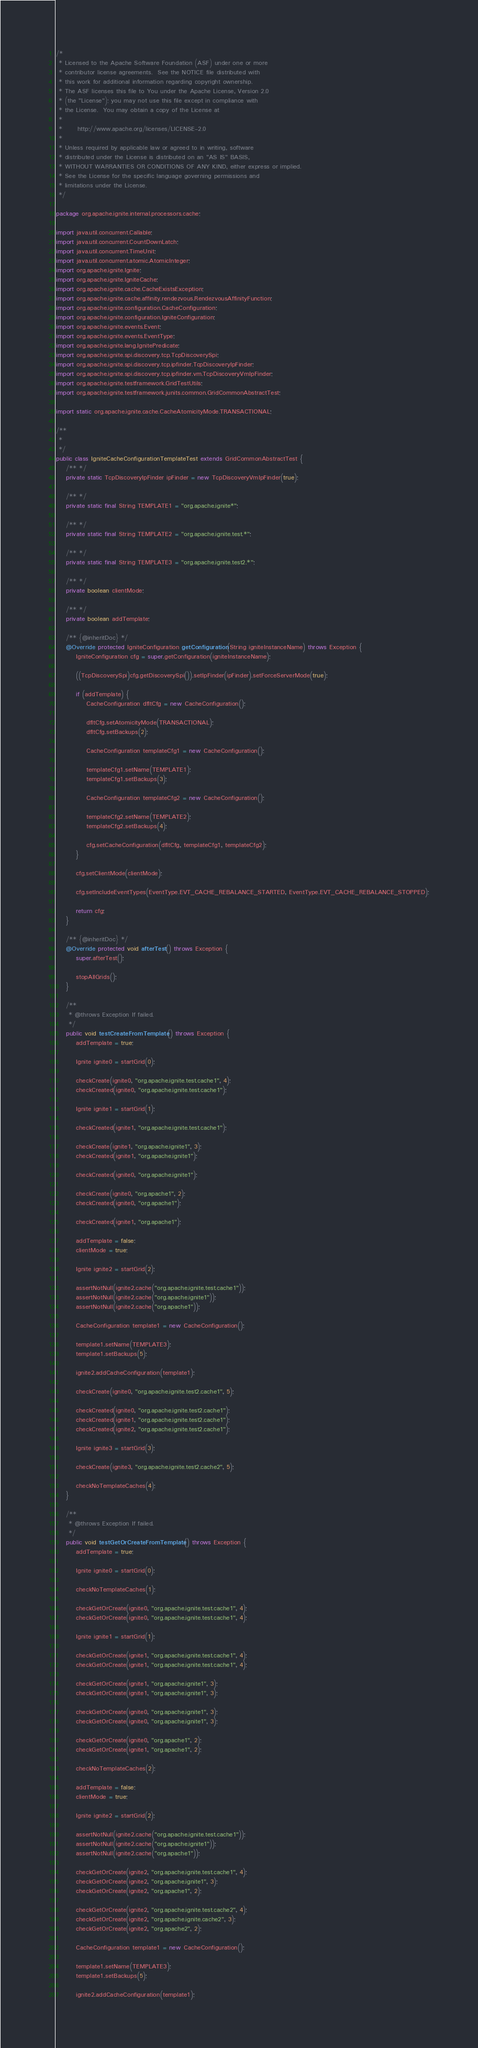<code> <loc_0><loc_0><loc_500><loc_500><_Java_>/*
 * Licensed to the Apache Software Foundation (ASF) under one or more
 * contributor license agreements.  See the NOTICE file distributed with
 * this work for additional information regarding copyright ownership.
 * The ASF licenses this file to You under the Apache License, Version 2.0
 * (the "License"); you may not use this file except in compliance with
 * the License.  You may obtain a copy of the License at
 *
 *      http://www.apache.org/licenses/LICENSE-2.0
 *
 * Unless required by applicable law or agreed to in writing, software
 * distributed under the License is distributed on an "AS IS" BASIS,
 * WITHOUT WARRANTIES OR CONDITIONS OF ANY KIND, either express or implied.
 * See the License for the specific language governing permissions and
 * limitations under the License.
 */

package org.apache.ignite.internal.processors.cache;

import java.util.concurrent.Callable;
import java.util.concurrent.CountDownLatch;
import java.util.concurrent.TimeUnit;
import java.util.concurrent.atomic.AtomicInteger;
import org.apache.ignite.Ignite;
import org.apache.ignite.IgniteCache;
import org.apache.ignite.cache.CacheExistsException;
import org.apache.ignite.cache.affinity.rendezvous.RendezvousAffinityFunction;
import org.apache.ignite.configuration.CacheConfiguration;
import org.apache.ignite.configuration.IgniteConfiguration;
import org.apache.ignite.events.Event;
import org.apache.ignite.events.EventType;
import org.apache.ignite.lang.IgnitePredicate;
import org.apache.ignite.spi.discovery.tcp.TcpDiscoverySpi;
import org.apache.ignite.spi.discovery.tcp.ipfinder.TcpDiscoveryIpFinder;
import org.apache.ignite.spi.discovery.tcp.ipfinder.vm.TcpDiscoveryVmIpFinder;
import org.apache.ignite.testframework.GridTestUtils;
import org.apache.ignite.testframework.junits.common.GridCommonAbstractTest;

import static org.apache.ignite.cache.CacheAtomicityMode.TRANSACTIONAL;

/**
 *
 */
public class IgniteCacheConfigurationTemplateTest extends GridCommonAbstractTest {
    /** */
    private static TcpDiscoveryIpFinder ipFinder = new TcpDiscoveryVmIpFinder(true);

    /** */
    private static final String TEMPLATE1 = "org.apache.ignite*";

    /** */
    private static final String TEMPLATE2 = "org.apache.ignite.test.*";

    /** */
    private static final String TEMPLATE3 = "org.apache.ignite.test2.*";

    /** */
    private boolean clientMode;

    /** */
    private boolean addTemplate;

    /** {@inheritDoc} */
    @Override protected IgniteConfiguration getConfiguration(String igniteInstanceName) throws Exception {
        IgniteConfiguration cfg = super.getConfiguration(igniteInstanceName);

        ((TcpDiscoverySpi)cfg.getDiscoverySpi()).setIpFinder(ipFinder).setForceServerMode(true);

        if (addTemplate) {
            CacheConfiguration dfltCfg = new CacheConfiguration();

            dfltCfg.setAtomicityMode(TRANSACTIONAL);
            dfltCfg.setBackups(2);

            CacheConfiguration templateCfg1 = new CacheConfiguration();

            templateCfg1.setName(TEMPLATE1);
            templateCfg1.setBackups(3);

            CacheConfiguration templateCfg2 = new CacheConfiguration();

            templateCfg2.setName(TEMPLATE2);
            templateCfg2.setBackups(4);

            cfg.setCacheConfiguration(dfltCfg, templateCfg1, templateCfg2);
        }

        cfg.setClientMode(clientMode);

        cfg.setIncludeEventTypes(EventType.EVT_CACHE_REBALANCE_STARTED, EventType.EVT_CACHE_REBALANCE_STOPPED);

        return cfg;
    }

    /** {@inheritDoc} */
    @Override protected void afterTest() throws Exception {
        super.afterTest();

        stopAllGrids();
    }

    /**
     * @throws Exception If failed.
     */
    public void testCreateFromTemplate() throws Exception {
        addTemplate = true;

        Ignite ignite0 = startGrid(0);

        checkCreate(ignite0, "org.apache.ignite.test.cache1", 4);
        checkCreated(ignite0, "org.apache.ignite.test.cache1");

        Ignite ignite1 = startGrid(1);

        checkCreated(ignite1, "org.apache.ignite.test.cache1");

        checkCreate(ignite1, "org.apache.ignite1", 3);
        checkCreated(ignite1, "org.apache.ignite1");

        checkCreated(ignite0, "org.apache.ignite1");

        checkCreate(ignite0, "org.apache1", 2);
        checkCreated(ignite0, "org.apache1");

        checkCreated(ignite1, "org.apache1");

        addTemplate = false;
        clientMode = true;

        Ignite ignite2 = startGrid(2);

        assertNotNull(ignite2.cache("org.apache.ignite.test.cache1"));
        assertNotNull(ignite2.cache("org.apache.ignite1"));
        assertNotNull(ignite2.cache("org.apache1"));

        CacheConfiguration template1 = new CacheConfiguration();

        template1.setName(TEMPLATE3);
        template1.setBackups(5);

        ignite2.addCacheConfiguration(template1);

        checkCreate(ignite0, "org.apache.ignite.test2.cache1", 5);

        checkCreated(ignite0, "org.apache.ignite.test2.cache1");
        checkCreated(ignite1, "org.apache.ignite.test2.cache1");
        checkCreated(ignite2, "org.apache.ignite.test2.cache1");

        Ignite ignite3 = startGrid(3);

        checkCreate(ignite3, "org.apache.ignite.test2.cache2", 5);

        checkNoTemplateCaches(4);
    }

    /**
     * @throws Exception If failed.
     */
    public void testGetOrCreateFromTemplate() throws Exception {
        addTemplate = true;

        Ignite ignite0 = startGrid(0);

        checkNoTemplateCaches(1);

        checkGetOrCreate(ignite0, "org.apache.ignite.test.cache1", 4);
        checkGetOrCreate(ignite0, "org.apache.ignite.test.cache1", 4);

        Ignite ignite1 = startGrid(1);

        checkGetOrCreate(ignite1, "org.apache.ignite.test.cache1", 4);
        checkGetOrCreate(ignite1, "org.apache.ignite.test.cache1", 4);

        checkGetOrCreate(ignite1, "org.apache.ignite1", 3);
        checkGetOrCreate(ignite1, "org.apache.ignite1", 3);

        checkGetOrCreate(ignite0, "org.apache.ignite1", 3);
        checkGetOrCreate(ignite0, "org.apache.ignite1", 3);

        checkGetOrCreate(ignite0, "org.apache1", 2);
        checkGetOrCreate(ignite1, "org.apache1", 2);

        checkNoTemplateCaches(2);

        addTemplate = false;
        clientMode = true;

        Ignite ignite2 = startGrid(2);

        assertNotNull(ignite2.cache("org.apache.ignite.test.cache1"));
        assertNotNull(ignite2.cache("org.apache.ignite1"));
        assertNotNull(ignite2.cache("org.apache1"));

        checkGetOrCreate(ignite2, "org.apache.ignite.test.cache1", 4);
        checkGetOrCreate(ignite2, "org.apache.ignite1", 3);
        checkGetOrCreate(ignite2, "org.apache1", 2);

        checkGetOrCreate(ignite2, "org.apache.ignite.test.cache2", 4);
        checkGetOrCreate(ignite2, "org.apache.ignite.cache2", 3);
        checkGetOrCreate(ignite2, "org.apache2", 2);

        CacheConfiguration template1 = new CacheConfiguration();

        template1.setName(TEMPLATE3);
        template1.setBackups(5);

        ignite2.addCacheConfiguration(template1);
</code> 